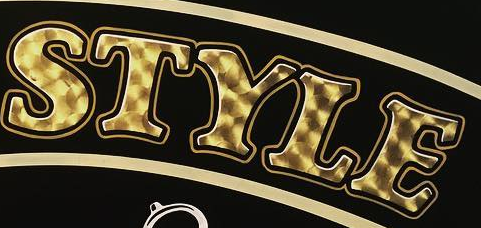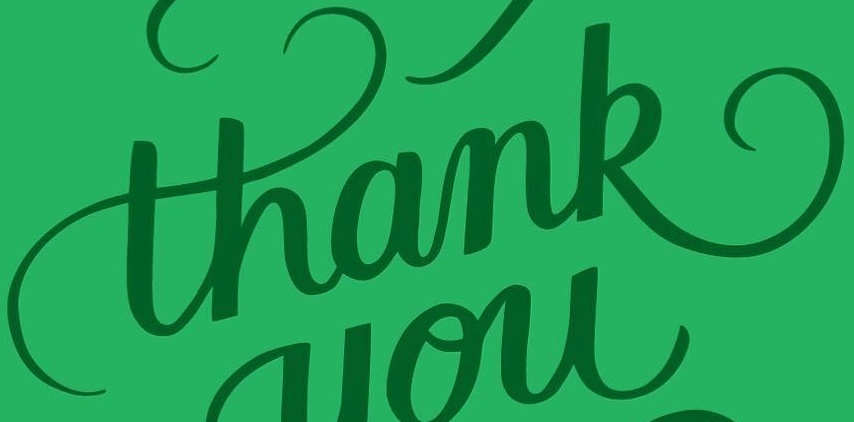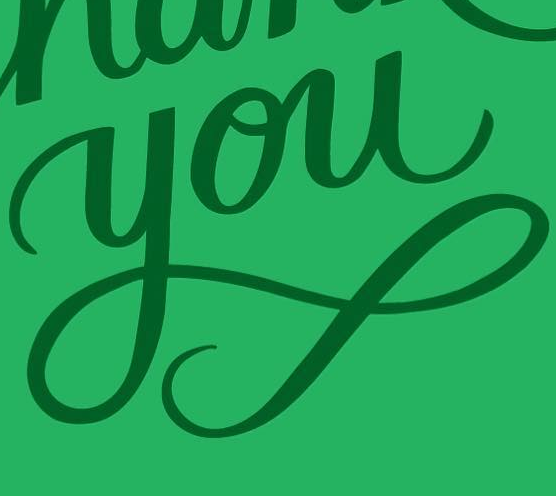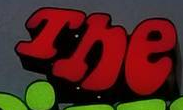Read the text from these images in sequence, separated by a semicolon. STYLE; thank; you; The 